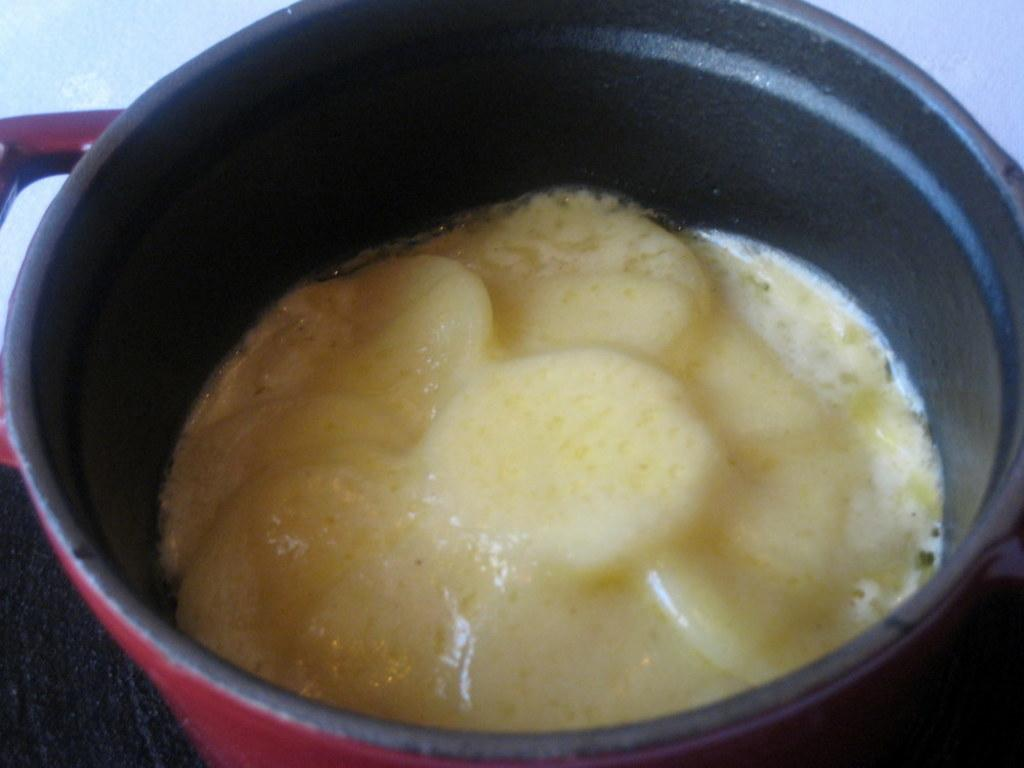What is present in the image? There is a bowl in the image. What is inside the bowl? The bowl contains food. What verse can be heard recited by the orange in the image? There is no orange present in the image, and therefore no verse can be heard. 